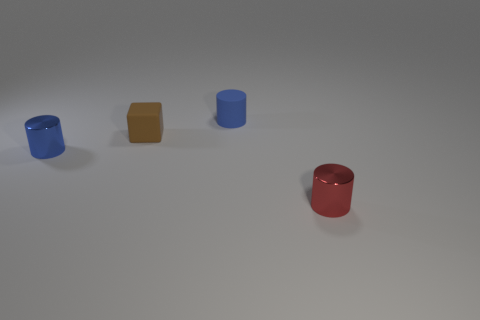Add 3 large cyan spheres. How many objects exist? 7 Subtract all cubes. How many objects are left? 3 Subtract 0 gray blocks. How many objects are left? 4 Subtract all blue matte cylinders. Subtract all small blue objects. How many objects are left? 1 Add 2 small blue cylinders. How many small blue cylinders are left? 4 Add 2 brown objects. How many brown objects exist? 3 